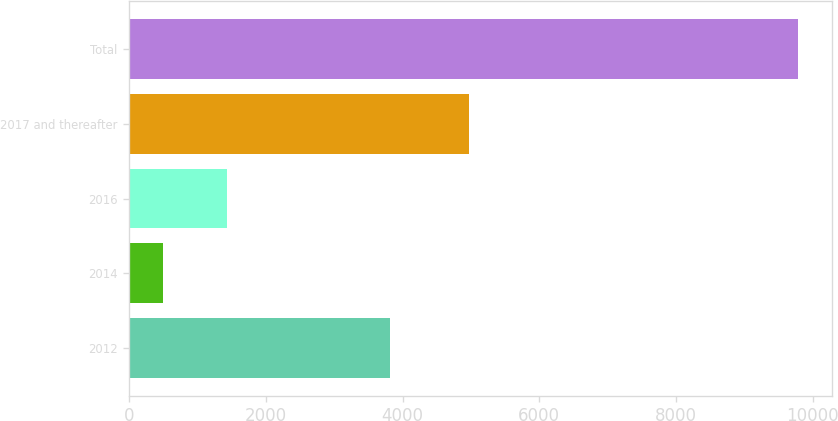Convert chart to OTSL. <chart><loc_0><loc_0><loc_500><loc_500><bar_chart><fcel>2012<fcel>2014<fcel>2016<fcel>2017 and thereafter<fcel>Total<nl><fcel>3811<fcel>500<fcel>1428.6<fcel>4975<fcel>9786<nl></chart> 